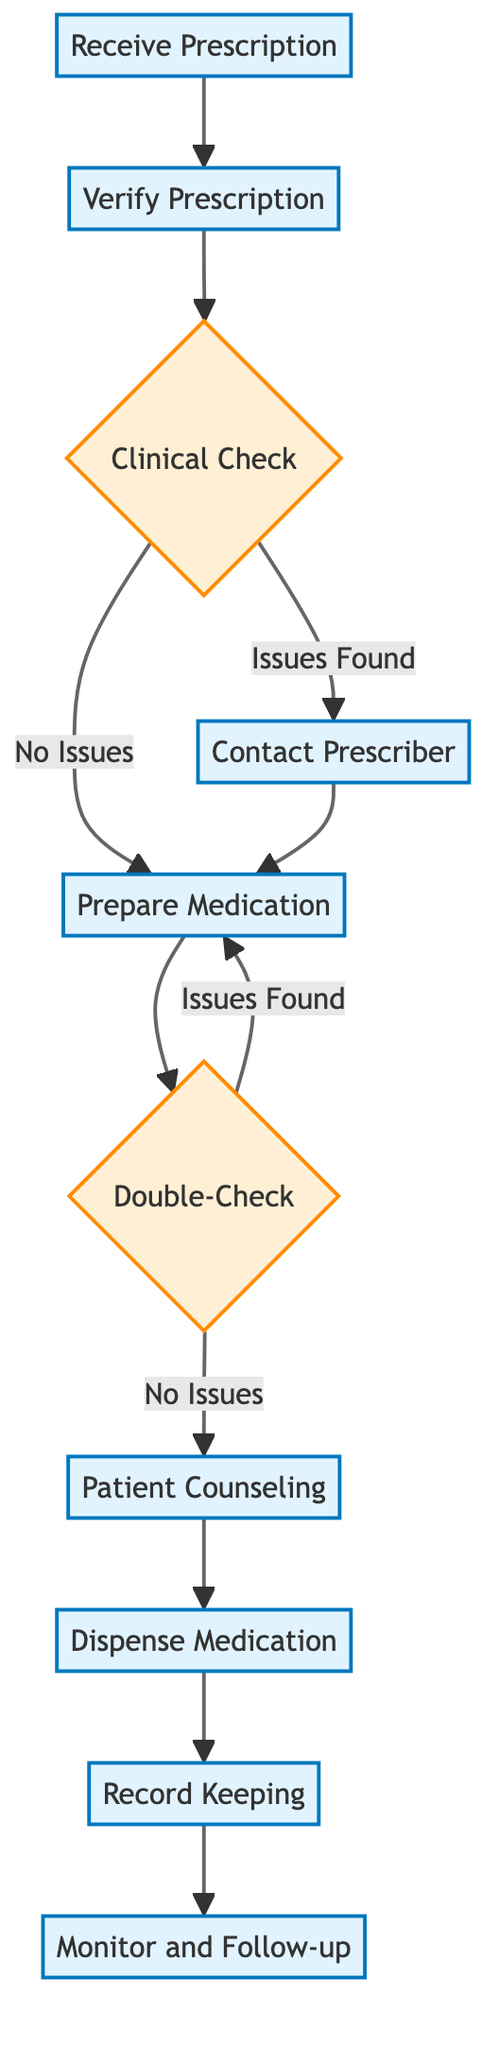What is the first step in the medication dispensing process? The diagram indicates that the first step is to "Receive Prescription." This is the starting node in the flow chart.
Answer: Receive Prescription How many steps are there in the medication dispensing process? By counting the nodes represented in the flow chart, we include steps 1 through 10, resulting in a total of 10 steps.
Answer: 10 What happens after the "Verify Prescription"? After "Verify Prescription," the next step is "Clinical Check." This is directly indicated in the diagram's flow from step 2 to step 3.
Answer: Clinical Check If issues are found during the "Clinical Check," what step follows? If issues are found during the "Clinical Check," the process leads to the "Contact Prescriber" step, as indicated by the directed edge from step 3 labeled "Issues Found."
Answer: Contact Prescriber What is the last step in the medication dispensing process? The last step according to the diagram flows from "Record Keeping" to "Monitor and Follow-up." The final node is "Monitor and Follow-up."
Answer: Monitor and Follow-up How many decision points are there in the flow chart? There are two decision points: "Clinical Check" and "Double-Check." These are indicated in the flow chart with curly braces, which represent decision nodes.
Answer: 2 What must be done before "Patient Counseling"? Before reaching "Patient Counseling," the step that must be completed is "Double-Check." The flow indicates that one cannot skip this step before counseling.
Answer: Double-Check What is the relationship between "Prepare Medication" and "Dispense Medication"? The flow chart shows that "Prepare Medication" must be completed before proceeding to "Dispense Medication." There is a direct arrow leading from step 5 to step 8.
Answer: Sequential Which step involves evaluating drug interactions and allergies? The "Clinical Check" step involves evaluating prescription details, including drug interactions and allergies. This is explicitly stated in its description within the diagram.
Answer: Clinical Check 